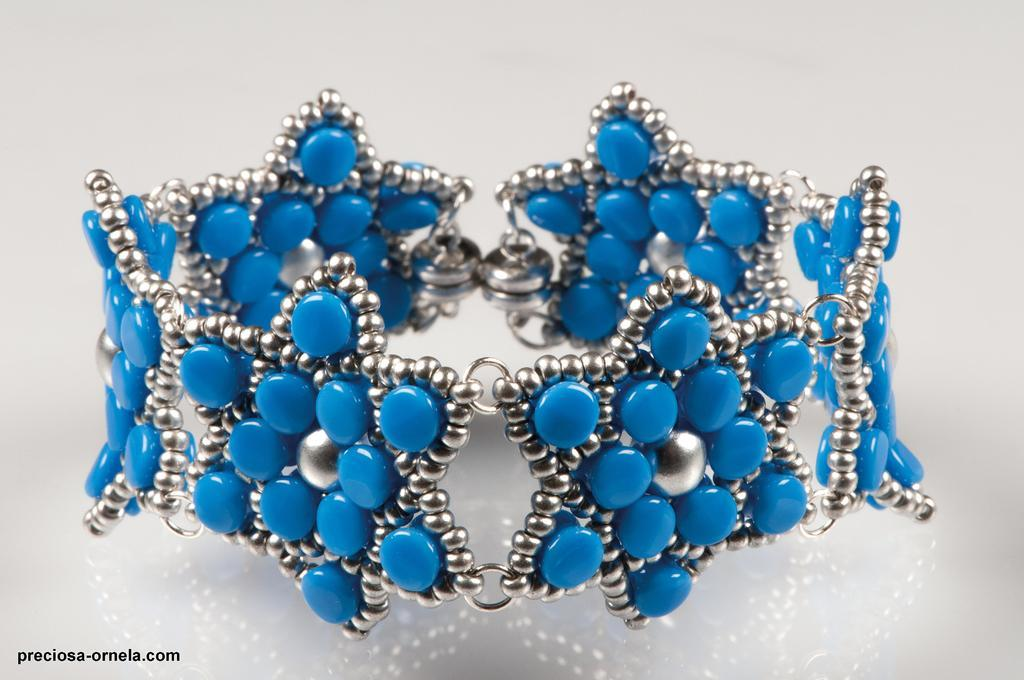What is the main subject of the image? The main subject of the image is a bracelet. Can you describe the bracelet in more detail? The bracelet is studded with blue color pearls. Is there any text present in the image? Yes, there is text in the bottom left corner of the image. How far away is the dog from the bracelet in the image? There is no dog present in the image, so it is not possible to determine the distance between the dog and the bracelet. 